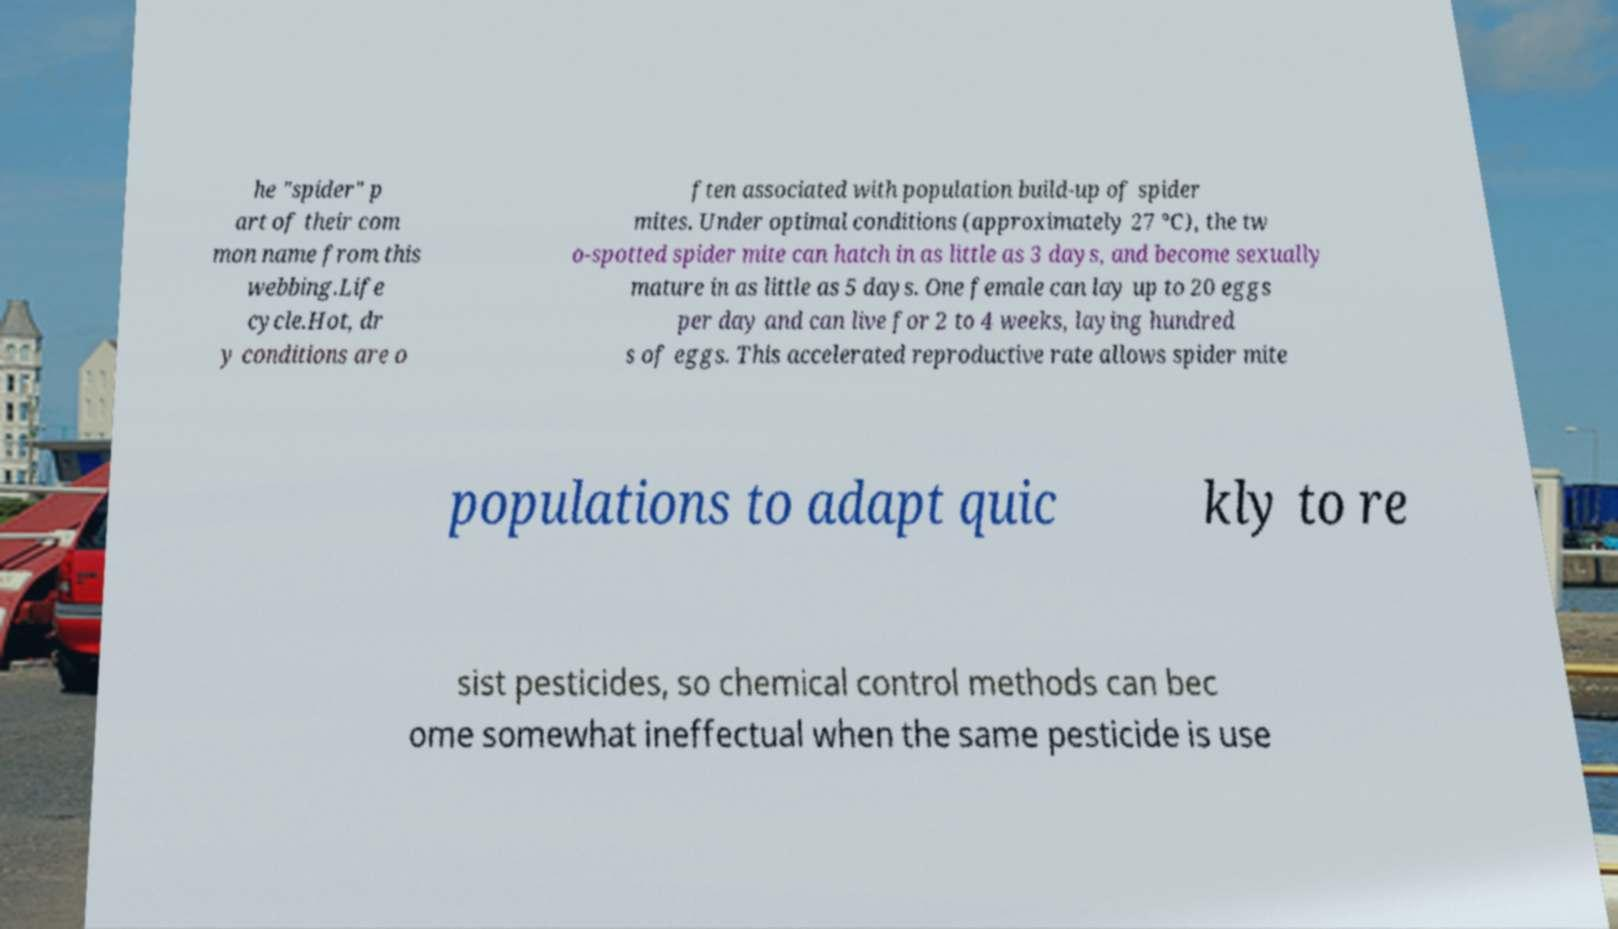Can you accurately transcribe the text from the provided image for me? he "spider" p art of their com mon name from this webbing.Life cycle.Hot, dr y conditions are o ften associated with population build-up of spider mites. Under optimal conditions (approximately 27 °C), the tw o-spotted spider mite can hatch in as little as 3 days, and become sexually mature in as little as 5 days. One female can lay up to 20 eggs per day and can live for 2 to 4 weeks, laying hundred s of eggs. This accelerated reproductive rate allows spider mite populations to adapt quic kly to re sist pesticides, so chemical control methods can bec ome somewhat ineffectual when the same pesticide is use 